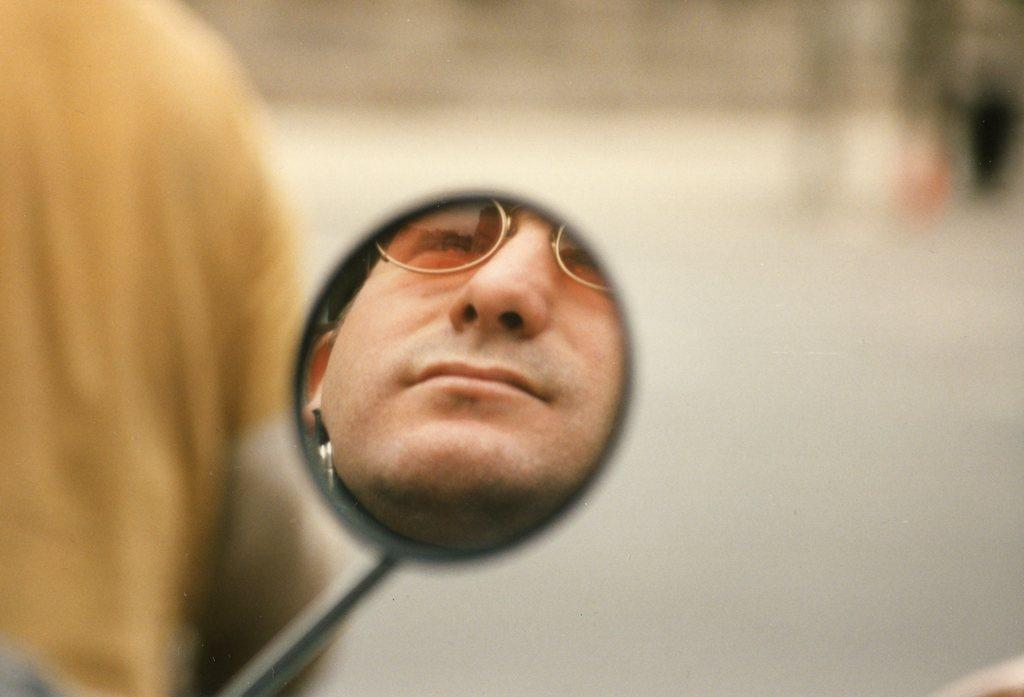What is the main subject of the image? The main subject of the image is a person's face visible in a mirror. Can you describe the other person in the image? There appears to be another person on the left side of the image. What type of rod is being used by the person in the image? There is no rod visible in the image. How many snakes are present in the image? There are no snakes present in the image. 